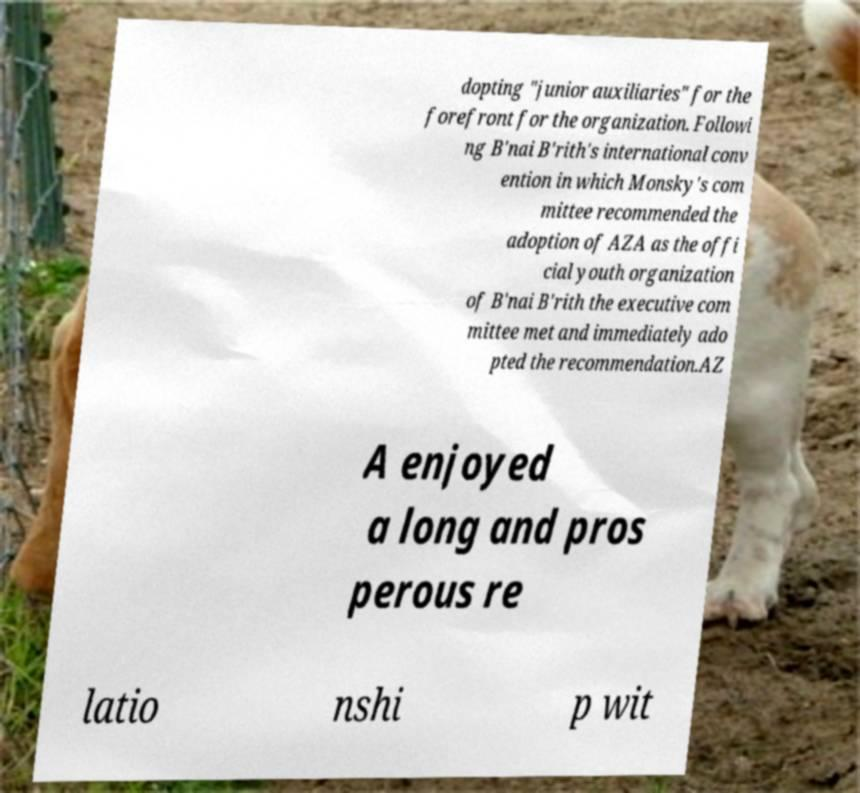I need the written content from this picture converted into text. Can you do that? dopting "junior auxiliaries" for the forefront for the organization. Followi ng B'nai B'rith's international conv ention in which Monsky's com mittee recommended the adoption of AZA as the offi cial youth organization of B'nai B'rith the executive com mittee met and immediately ado pted the recommendation.AZ A enjoyed a long and pros perous re latio nshi p wit 